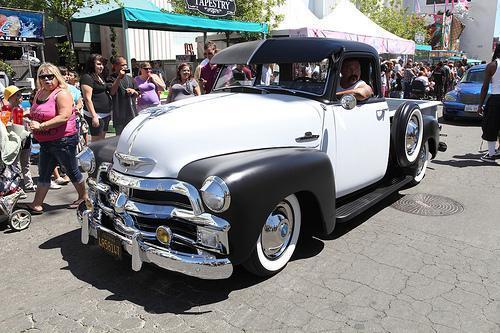How many headlights does the truck have?
Give a very brief answer. 2. 